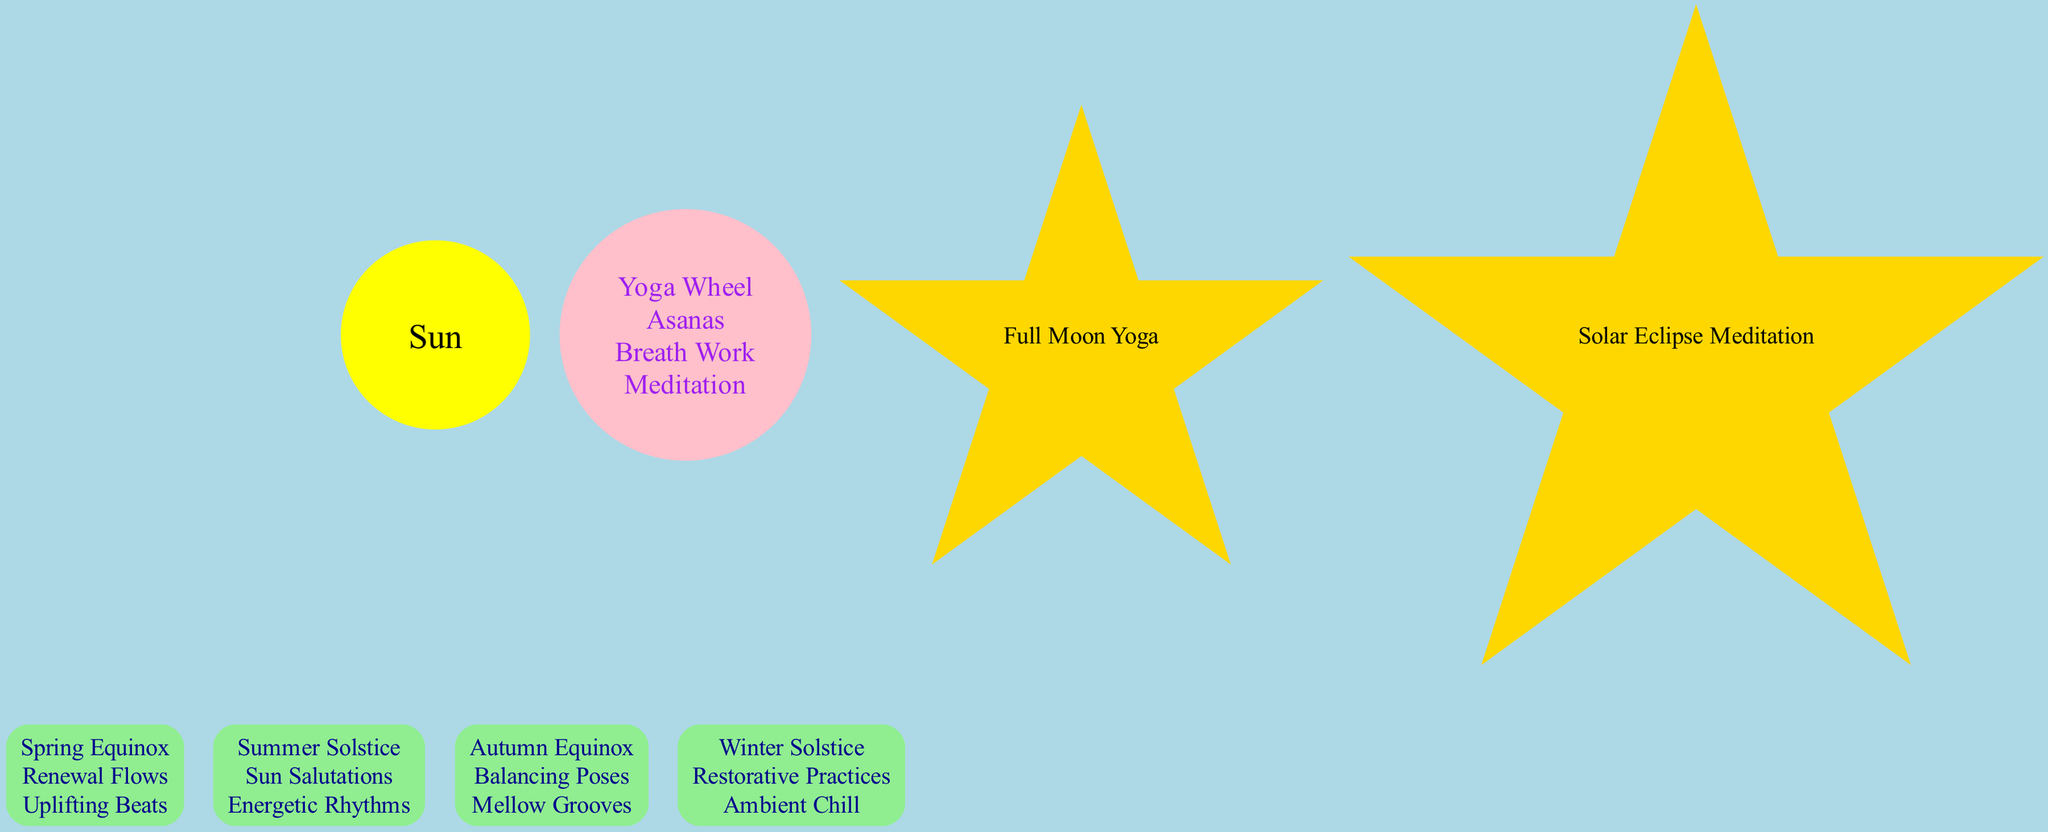What is at the center of the diagram? The diagram clearly indicates that the "Sun" is at the center, represented by a yellow circle. This is the focal point from which the Earth's orbit is designed.
Answer: Sun How many seasons are represented in the diagram? There are four seasons listed around the Sun: Spring Equinox, Summer Solstice, Autumn Equinox, and Winter Solstice. This information can be counted directly from the nodes labeled with the season names.
Answer: 4 What is the yoga focus associated with the Summer Solstice? The node for "Summer Solstice" specifies that its yoga focus is "Sun Salutations". This directly correlates to the information seen in that specific box node.
Answer: Sun Salutations Which celestial event involves meditation? The celestial event labeled "Solar Eclipse Meditation" directly signifies that meditation is associated with this event. It can be identified from the star-shaped node in the diagram.
Answer: Solar Eclipse Meditation What does the inner circle of the yoga wheel represent? The data specifies that the inner circle of the yoga wheel represents "Asanas", a fundamental yoga practice present in the visual depiction of the yoga wheel.
Answer: Asanas Which season corresponds to the playlist "Uplifting Beats"? The "Spring Equinox" season is connected to the playlist "Uplifting Beats", as described in the associated information within that node.
Answer: Spring Equinox How many total yoga focuses are mentioned? Each of the four seasons has one unique yoga focus attributed to it, totaling four distinct yoga focuses. Each can be deduced from the yoga focus specified in each seasonal node.
Answer: 4 What color represents the yoga wheel in the diagram? The yoga wheel is depicted with a pink color, as detailed within its node formatting in the diagram.
Answer: Pink What type of yoga event is associated with the full moon? The "Full Moon Yoga" is the specific event mentioned in the celestial events part of the diagram, indicating a yoga practice tied to this lunar phase.
Answer: Full Moon Yoga 